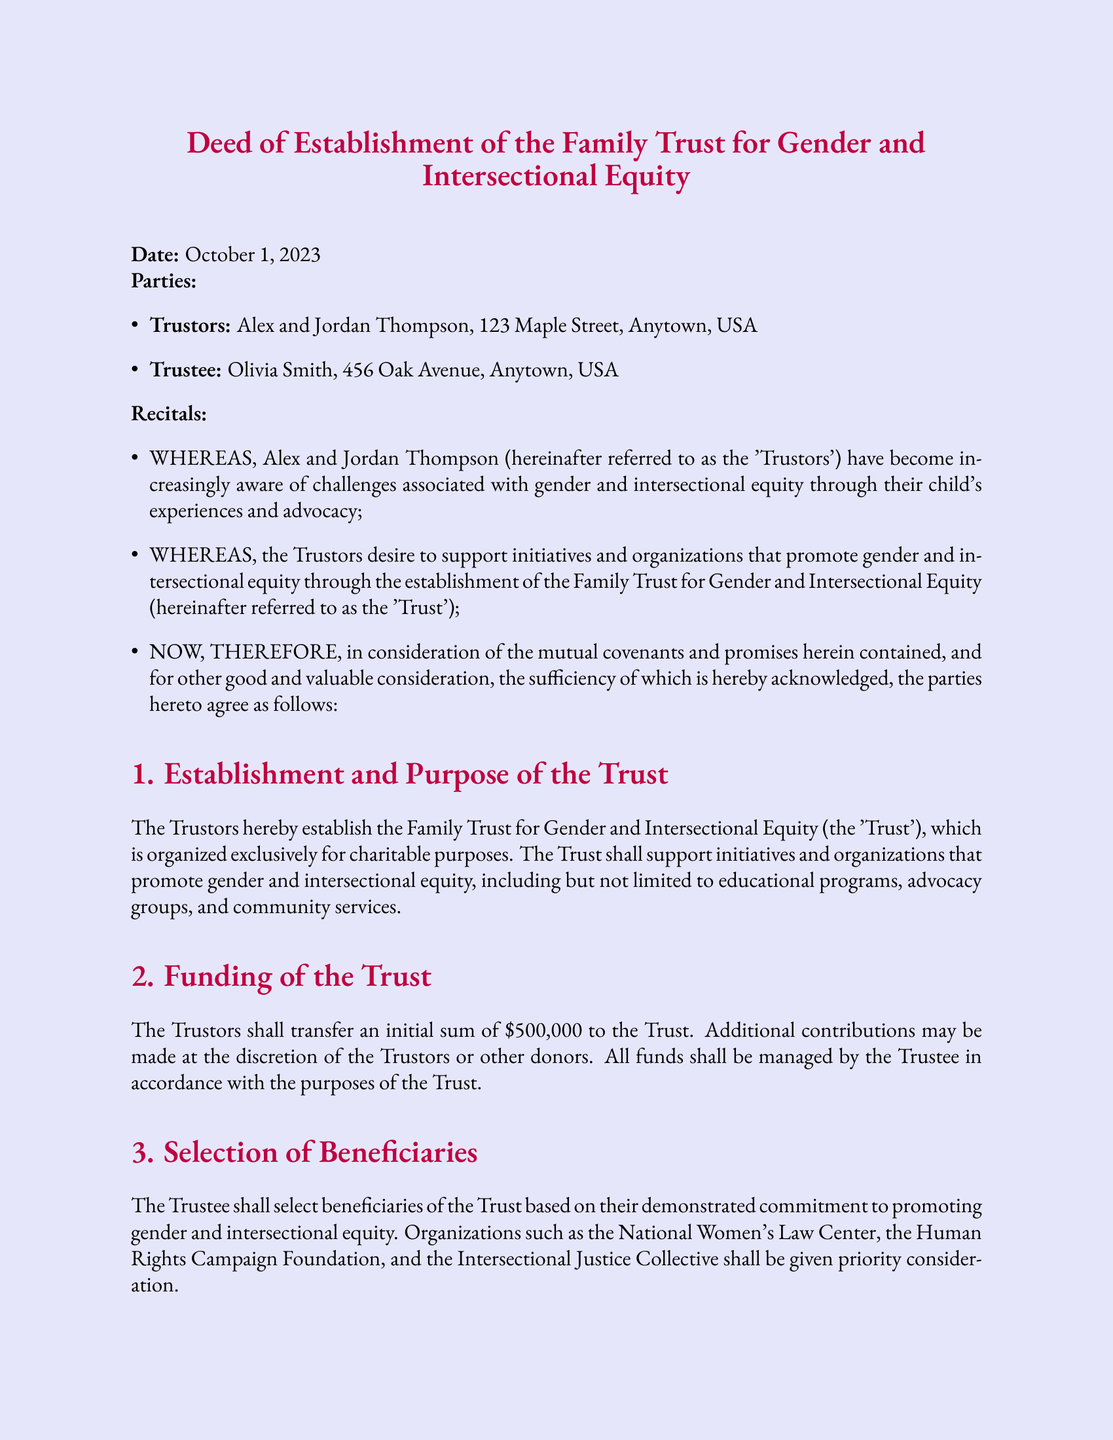What is the date of the deed? The date of the deed is specified at the beginning of the document.
Answer: October 1, 2023 Who are the Trustors? The Trustors are named in the parties section of the document.
Answer: Alex and Jordan Thompson What is the initial funding amount of the Trust? The initial funding amount is mentioned in the Funding section of the document.
Answer: $500,000 Who is the Trustee? The Trustee is identified in the parties section of the document.
Answer: Olivia Smith What is the duration of the Trust? The duration is specified in the Duration and Termination section of the document.
Answer: 50 years Which organizations are prioritized as beneficiaries? The beneficiaries are listed in the Selection of Beneficiaries section of the document.
Answer: National Women's Law Center, the Human Rights Campaign Foundation, and the Intersectional Justice Collective What is the purpose of the Trust? The purpose is stated at the beginning of the Establishment and Purpose of the Trust section.
Answer: To support initiatives and organizations that promote gender and intersectional equity What powers does the Trustee have? The powers of the Trustee are outlined in the Trustee's Duties and Powers section of the document.
Answer: Manage and disburse the Trust's assets What happens to remaining assets upon termination of the Trust? The distribution of remaining assets is explained in the Duration and Termination of the Trust section.
Answer: Distributed to qualified charitable organizations 